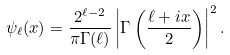<formula> <loc_0><loc_0><loc_500><loc_500>\psi _ { \ell } ( x ) = \frac { 2 ^ { \ell - 2 } } { \pi \Gamma ( \ell ) } \left | \Gamma \left ( \frac { \ell + i x } { 2 } \right ) \right | ^ { 2 } .</formula> 